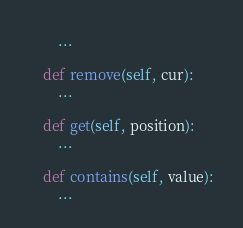<code> <loc_0><loc_0><loc_500><loc_500><_Python_>		...

	def remove(self, cur):
		...

	def get(self, position):
		...

	def contains(self, value):
		...</code> 